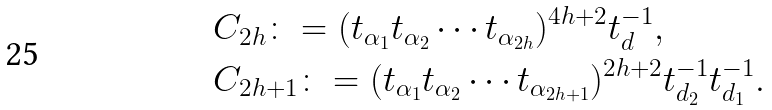<formula> <loc_0><loc_0><loc_500><loc_500>& C _ { 2 h } \colon = ( t _ { \alpha _ { 1 } } t _ { \alpha _ { 2 } } \cdots t _ { \alpha _ { 2 h } } ) ^ { 4 h + 2 } t _ { d } ^ { - 1 } , \\ & C _ { 2 h + 1 } \colon = ( t _ { \alpha _ { 1 } } t _ { \alpha _ { 2 } } \cdots t _ { \alpha _ { 2 h + 1 } } ) ^ { 2 h + 2 } t _ { d _ { 2 } } ^ { - 1 } t _ { d _ { 1 } } ^ { - 1 } .</formula> 